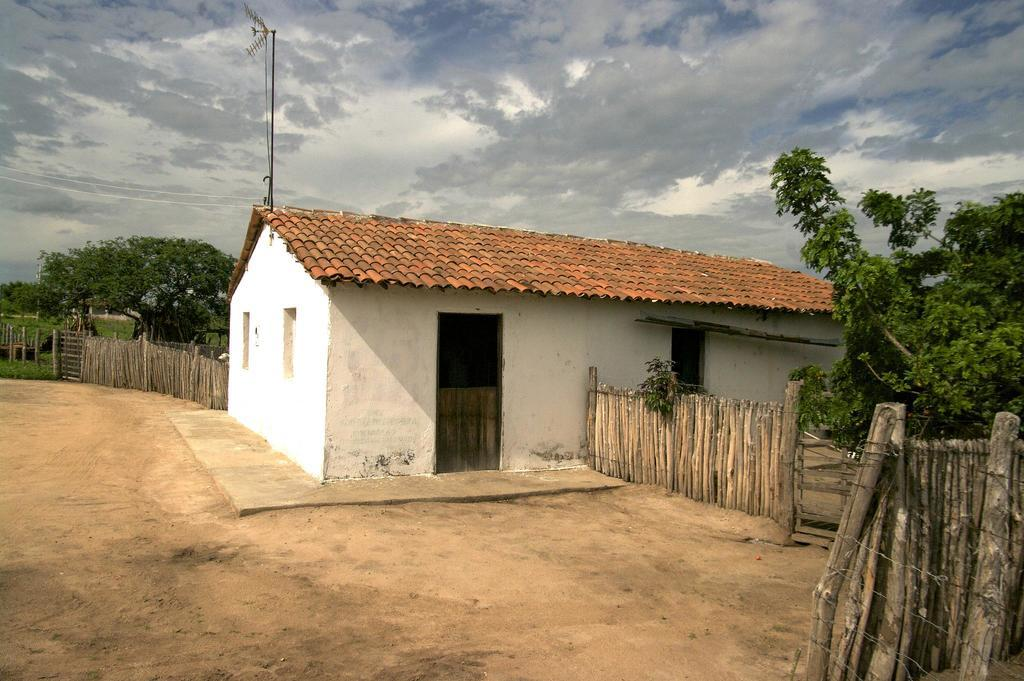What type of structure is visible in the image? There is a house in the image. What is the material of the fencing near the house? The fencing in the image is made of wood. What can be seen in the background of the image? There are trees and a pole in the background of the image. What is the color of the trees in the image? The trees are green in color. What is the color of the sky in the image? The sky is blue and white in color. What is the number of thumbs on the trees in the image? There are no thumbs on the trees in the image, as trees do not have thumbs. 